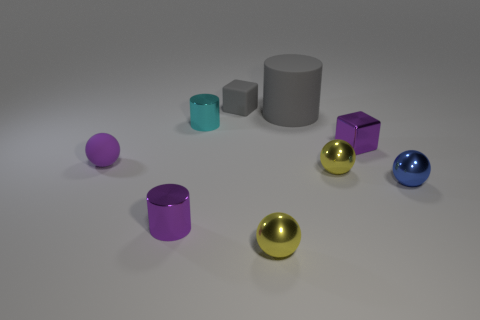How does the texture of the different objects in the image compare? The objects all possess a smooth and reflective texture, giving them a sleek appearance. However, the varying colors and materials create a subtle interplay of light, which would feel unique to the touch for each object. 